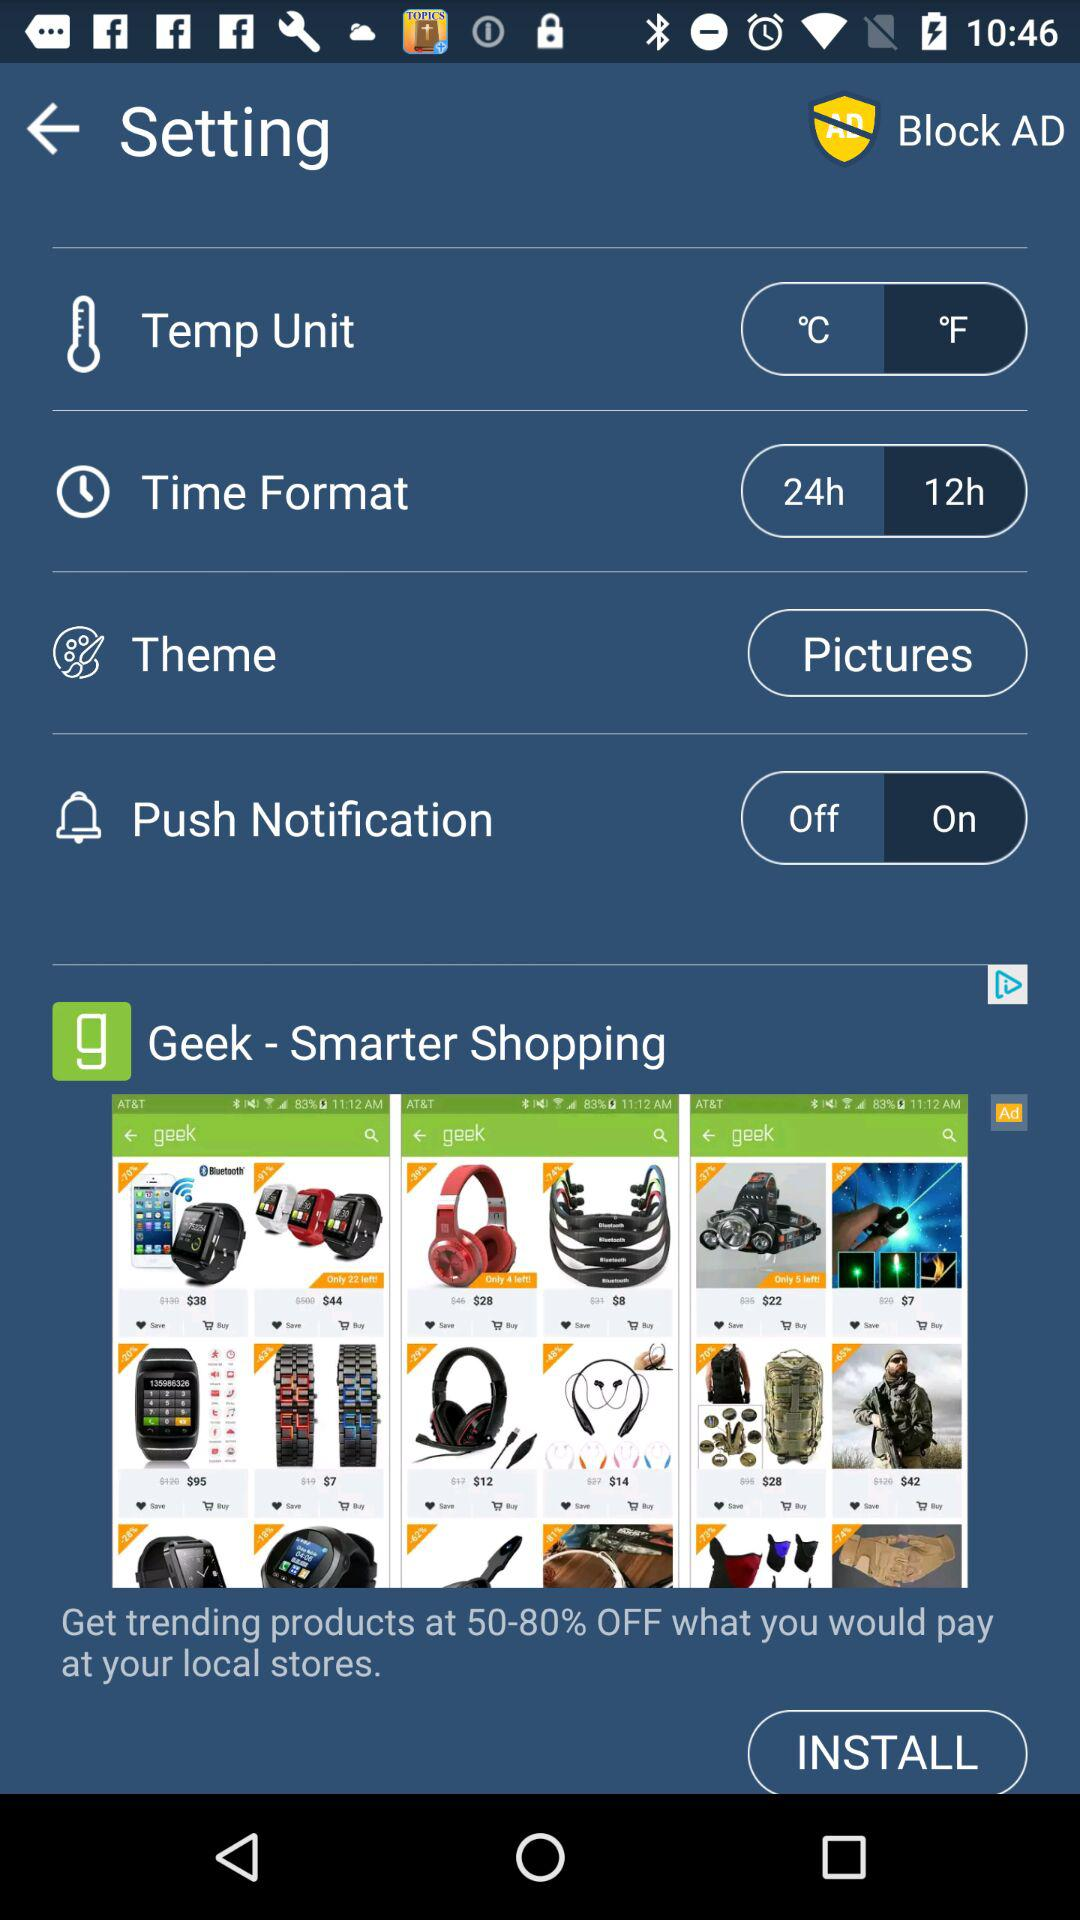What is the unit of the temperature? The unit of the temperature is °F. 